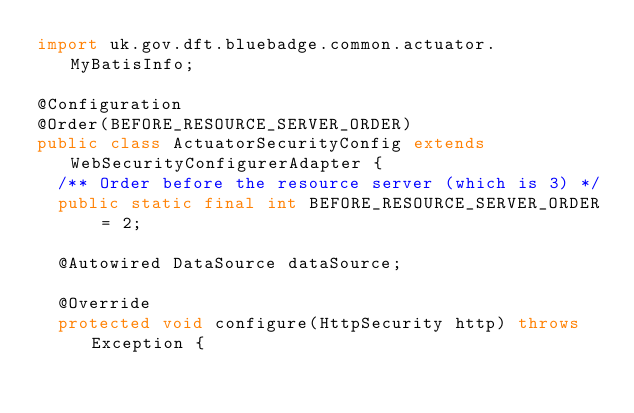<code> <loc_0><loc_0><loc_500><loc_500><_Java_>import uk.gov.dft.bluebadge.common.actuator.MyBatisInfo;

@Configuration
@Order(BEFORE_RESOURCE_SERVER_ORDER)
public class ActuatorSecurityConfig extends WebSecurityConfigurerAdapter {
  /** Order before the resource server (which is 3) */
  public static final int BEFORE_RESOURCE_SERVER_ORDER = 2;

  @Autowired DataSource dataSource;

  @Override
  protected void configure(HttpSecurity http) throws Exception {</code> 